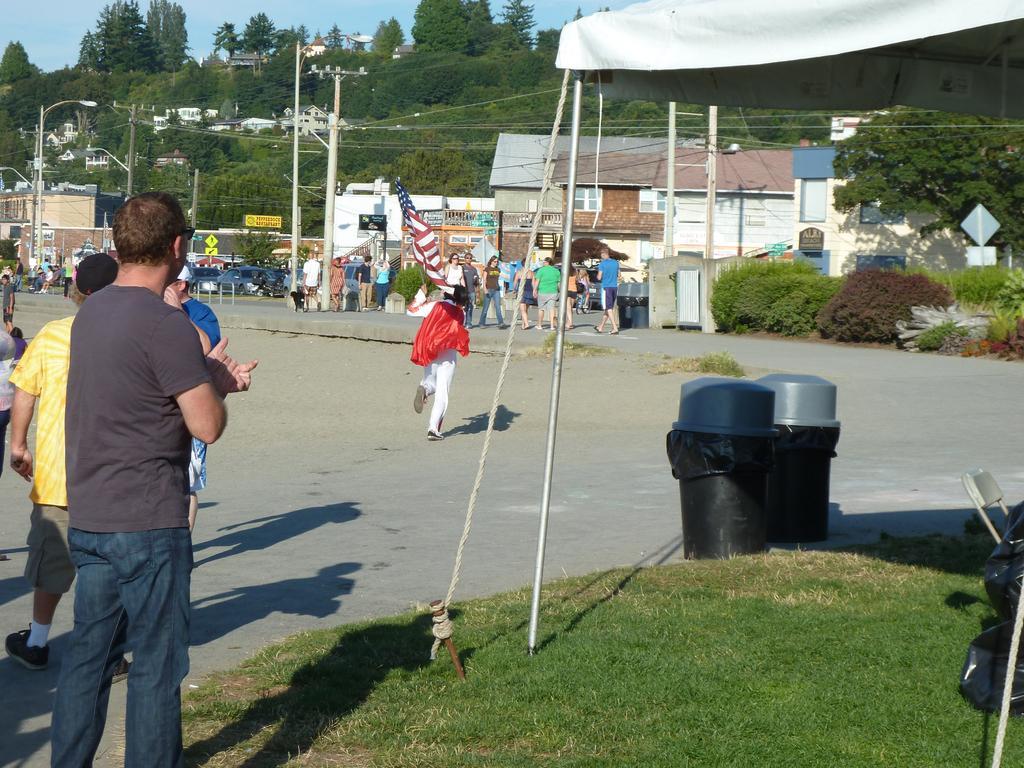Please provide a concise description of this image. This picture might be taken from outside of the city and it is sunny. In this image, on the left side, we can see a group of people. In the middle of the image, we can see a person walking on the road, he is also holding a flag in his hand. On the right side, we can see a tent, chair and two boxes. In the background, we can see group of people, flags, cars, trees, street lights, electrical pole, electrical wires, buildings, trees. On the top, we can see a sky, at the bottom there is a road and a grass. 